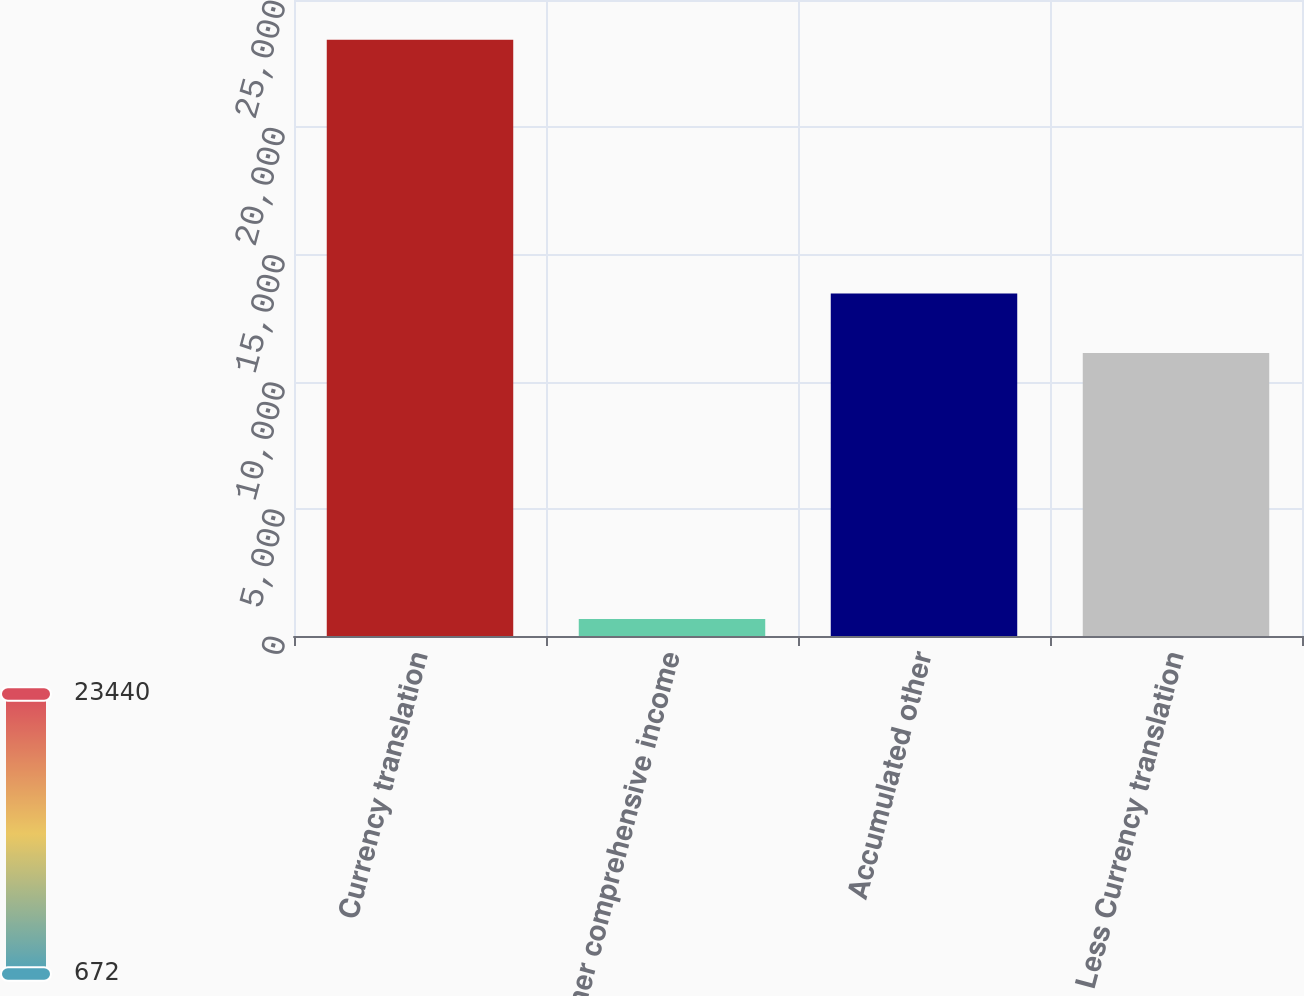Convert chart to OTSL. <chart><loc_0><loc_0><loc_500><loc_500><bar_chart><fcel>Currency translation<fcel>Other comprehensive income<fcel>Accumulated other<fcel>Less Currency translation<nl><fcel>23440<fcel>672<fcel>13465<fcel>11121<nl></chart> 